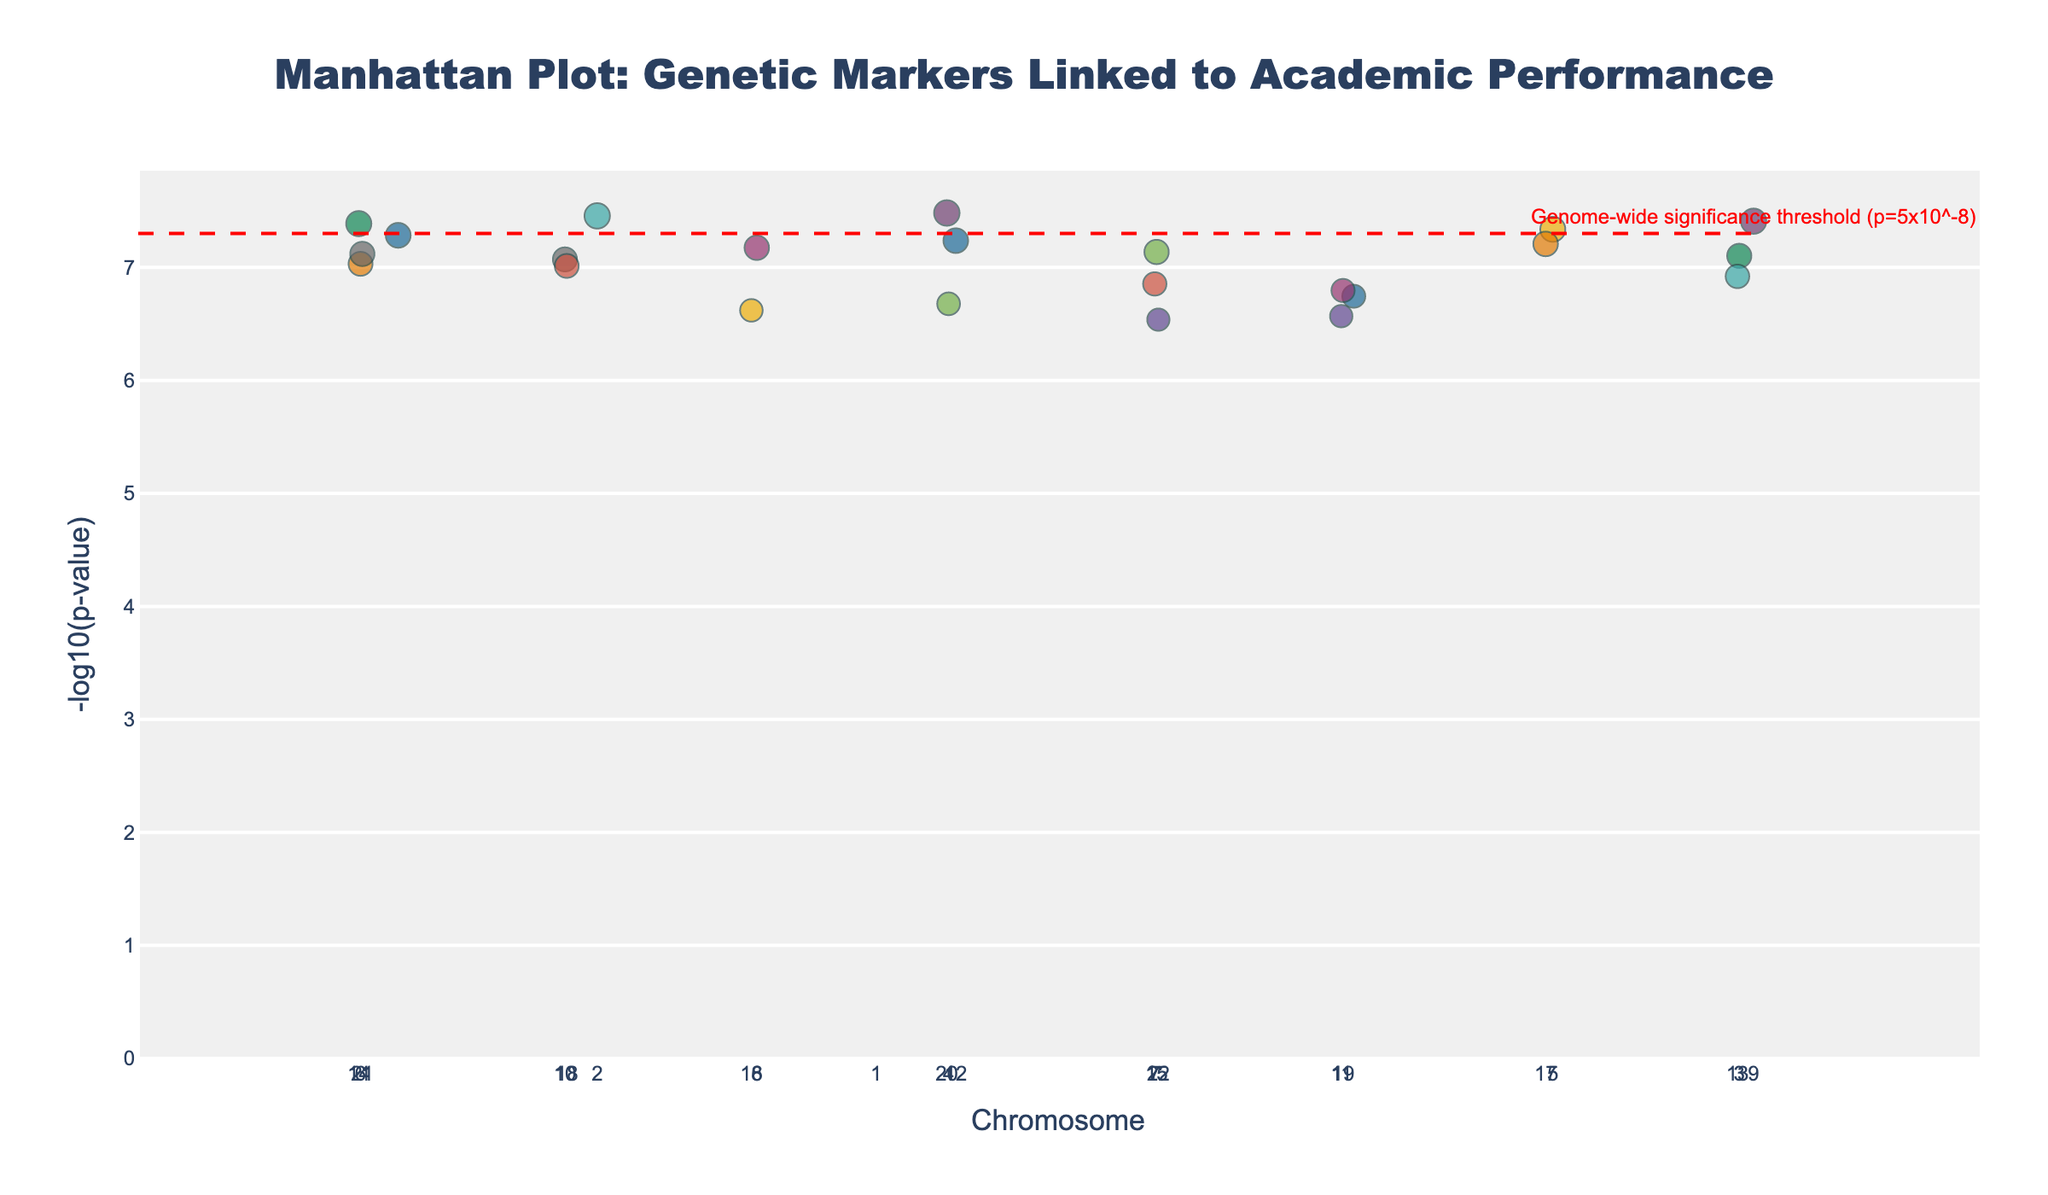What is the title of the Manhattan Plot? Look at the top of the figure where the title is usually located.
Answer: Manhattan Plot: Genetic Markers Linked to Academic Performance What does the y-axis represent in this plot? The y-axis label is displayed along the y-axis.
Answer: -log10(p-value) How many chromosomes are represented in the plot? Count the distinct tick marks on the x-axis representing chromosomes.
Answer: 22 Which chromosome has the highest -log10(p-value) data point, and what trait is associated with it? Locate the highest point on the plot along the y-axis and identify the corresponding chromosome and the trait in the hover info or legend.
Answer: Chromosome 1, Reading comprehension What is the genome-wide significance threshold, and how is it depicted in the plot? Identify the line and annotation regarding significance; the threshold line is typically horizontal and might be dashed with a color annotation.
Answer: p=5x10^-8, depicted as a red dashed line Which chromosomes have more than one significant SNP according to the plot? Look for multiple markers above the red threshold line in the same chromosome indicated by different colors for each chromosome.
Answer: Chromosomes 1, 2, 4 What is the -log10(p-value) for the SNP associated with working memory? Locate the SNP associated with working memory in hover info or legend and read off the y-axis value.
Answer: Approximately 7.1 How does the scatter point size vary in this plot? Examine the point sizes and match it with the size scaling in the explanation. Larger points indicate lower p-values due to -log10 scaling.
Answer: The size varies based on p-value significance; more significant SNPs are larger Which trait is associated with the SNP at the lowest chromosome number and lowest position? Look at the SNP with the smallest position on the lowest chromosome number and identify the trait in hover info.
Answer: Reading comprehension How many traits have SNPs with -log10(p-value) greater than 8? Identify and count the points above this threshold on the y-axis, referring to hover info to see the traits.
Answer: 2 (Reading comprehension and Verbal reasoning) 